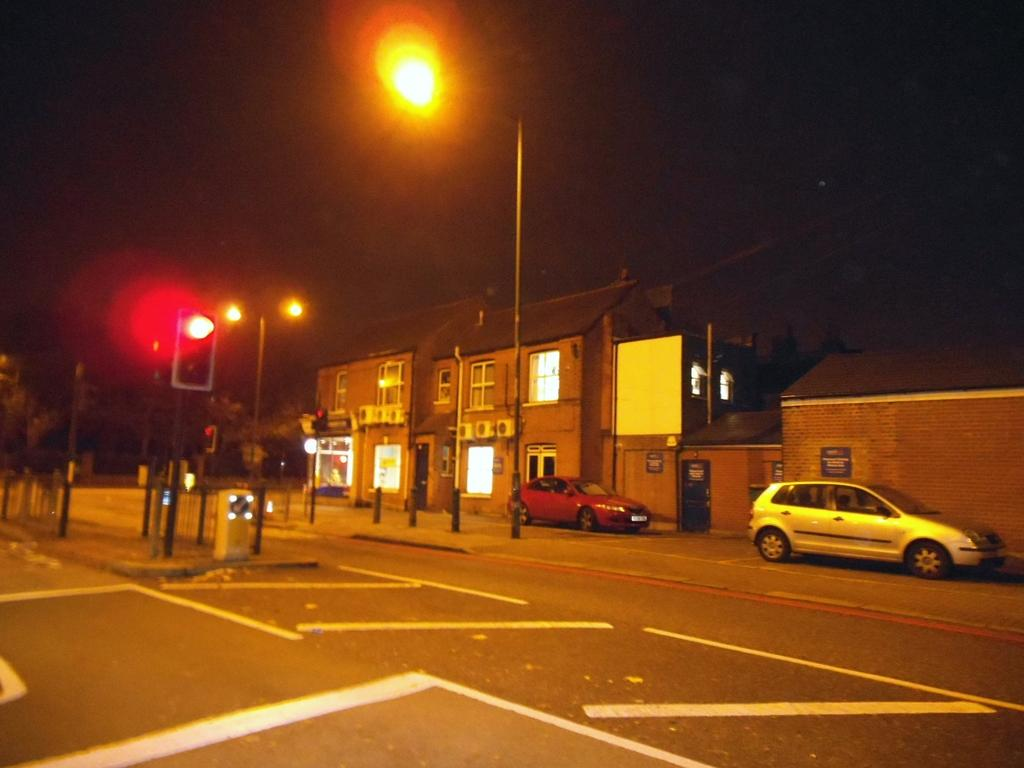What structures are present in the image? There are poles, a traffic signal, boards, and buildings in the image. What type of illumination is visible in the image? There are lights in the image. What type of vehicles can be seen in the image? There are cars on the road in the image. What natural elements are present in the image? There are trees in the image. What is visible in the background of the image? There is sky visible in the background of the image. What type of doll can be seen holding a print of letters in the image? There is no doll or print of letters present in the image. 